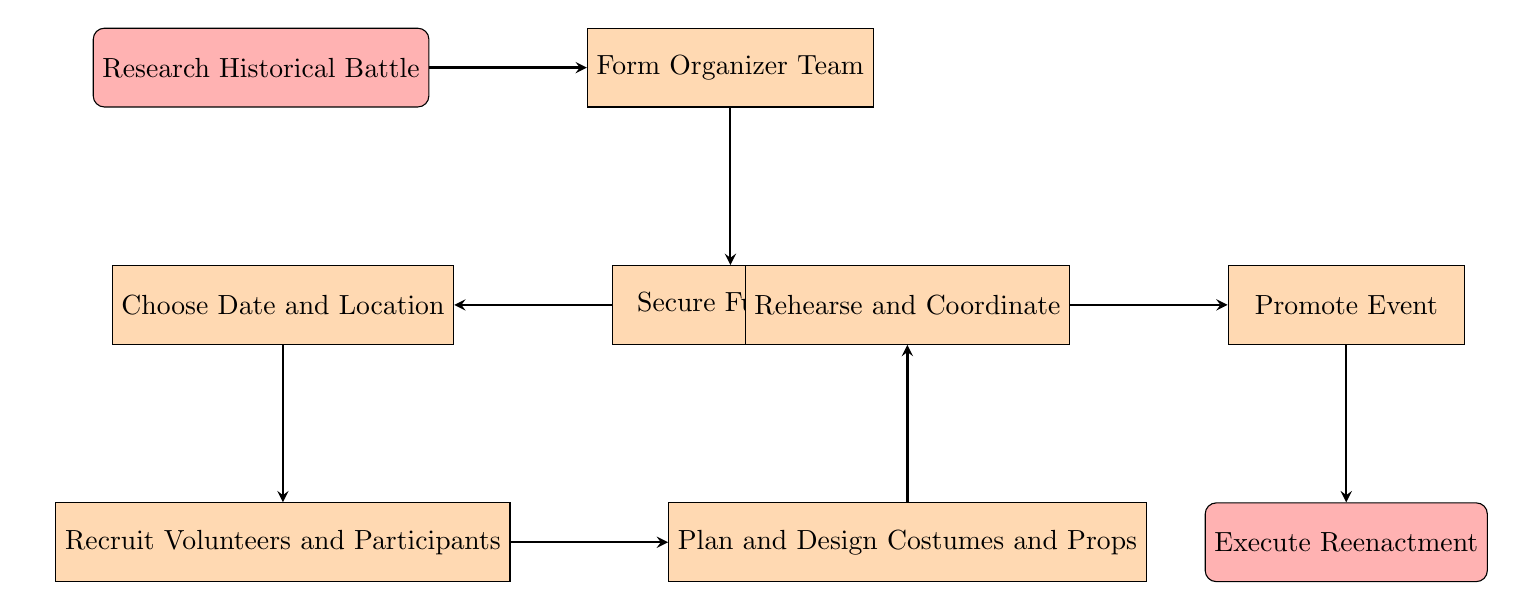What is the first step in the flow chart? The first node in the flow chart is "Research Historical Battle," which identifies it as the initial action to be taken.
Answer: Research Historical Battle How many main steps are there in the flow chart? By counting the nodes in the diagram, there are a total of eight main steps involved in organizing a historical reenactment event.
Answer: Eight What step comes after securing funding? From the flow of the diagram, the step that follows "Secure Funding" is "Choose Date and Location."
Answer: Choose Date and Location What is the last step of the process? The diagram indicates that "Execute Reenactment" is the final step, completing the flow of the organization process.
Answer: Execute Reenactment Which step is directly before "Promote Event"? Referring to the flow chart, the step that directly precedes "Promote Event" is "Rehearse and Coordinate."
Answer: Rehearse and Coordinate How does one proceed after recruiting volunteers and participants? According to the flow chart, the next step after "Recruit Volunteers and Participants" is "Plan and Design Costumes and Props.”
Answer: Plan and Design Costumes and Props What role should the organizer team include? The description for "Form Organizer Team" states that it should include historians, logistics experts, and costume designers, suggesting a collaborative role in the team structure.
Answer: Historians, logistics experts, costume designers How are participants recruited as shown in the process? The "Recruit Volunteers and Participants" step indicates that participants can be found through history clubs, social media, and local universities, showcasing a diverse recruitment approach.
Answer: History clubs, social media, local universities What should be done after promoting the event? The diagram specifies that after promoting the event, the next action is to "Execute Reenactment," indicating a clear progression towards the event day.
Answer: Execute Reenactment 